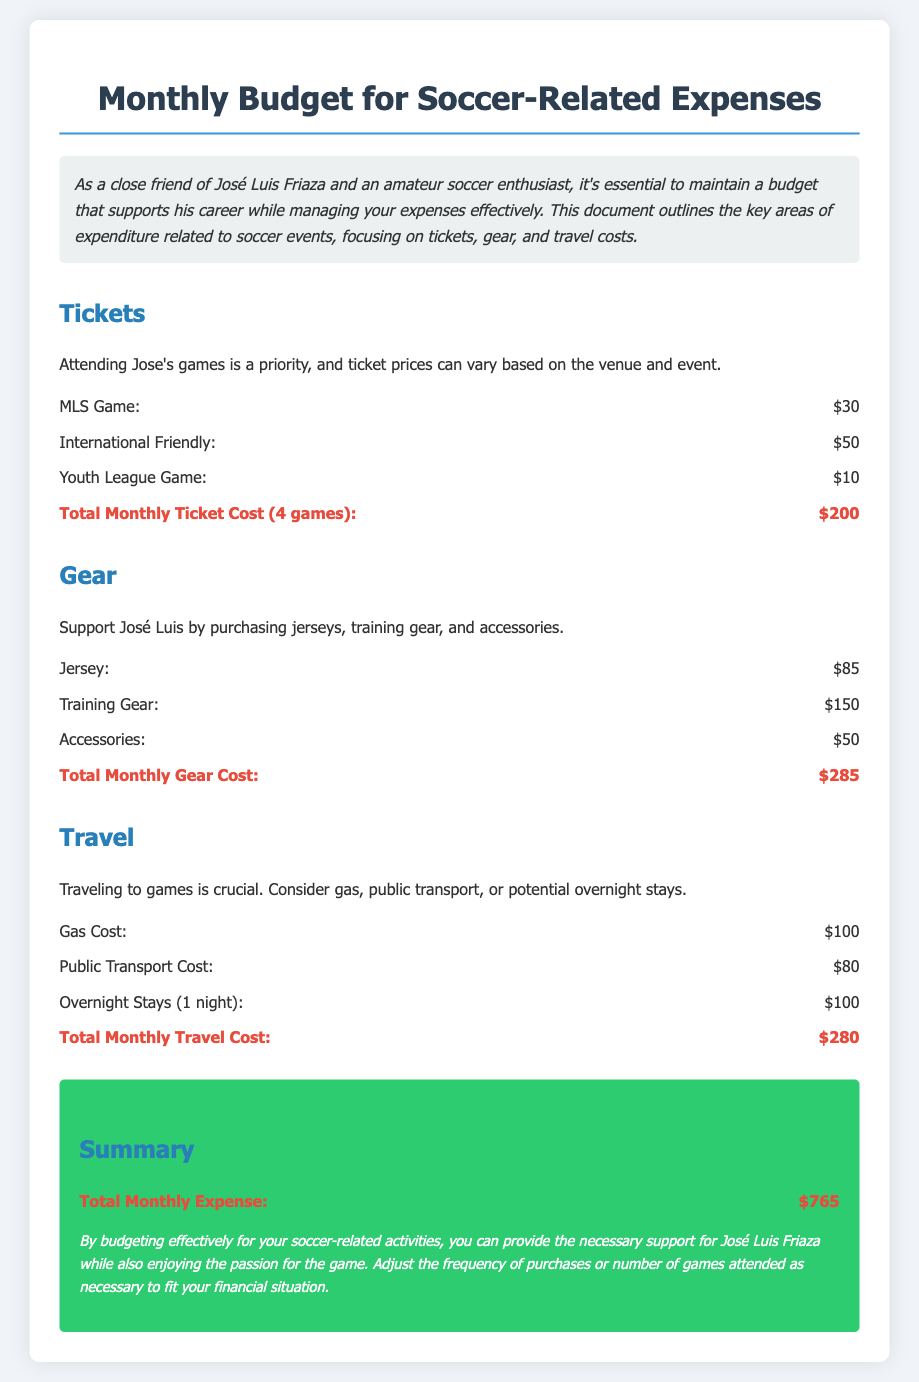What is the total monthly ticket cost? The total monthly ticket cost is calculated from the individual ticket prices for 4 games, which adds up to $200.
Answer: $200 What is the cost of a jersey? The document lists the price of a jersey as part of gear expenses.
Answer: $85 What is the total monthly gear cost? The total monthly gear cost is the sum of the costs for the jersey, training gear, and accessories, which equals $285.
Answer: $285 What is the gas cost for travel? The document specifies the gas cost under the travel section.
Answer: $100 What is the total monthly travel cost? The total monthly travel cost is the sum of gas, public transport, and overnight stays, which amounts to $280.
Answer: $280 What is mentioned as a priority regarding tickets? The document emphasizes attending José's games as a priority, indicating the significance of tickets.
Answer: Attending José's games How much can I expect to spend on travel if I decide on public transport? The document specifies the cost of public transport as part of travel expenses.
Answer: $80 What is the total monthly expense as per the summary? According to the summary section, the total monthly expense is a comprehensive figure that includes all costs.
Answer: $765 Which type of games has the lowest ticket price? The document mentions ticket prices for different types of games, identifying the one with the lowest price.
Answer: Youth League Game 